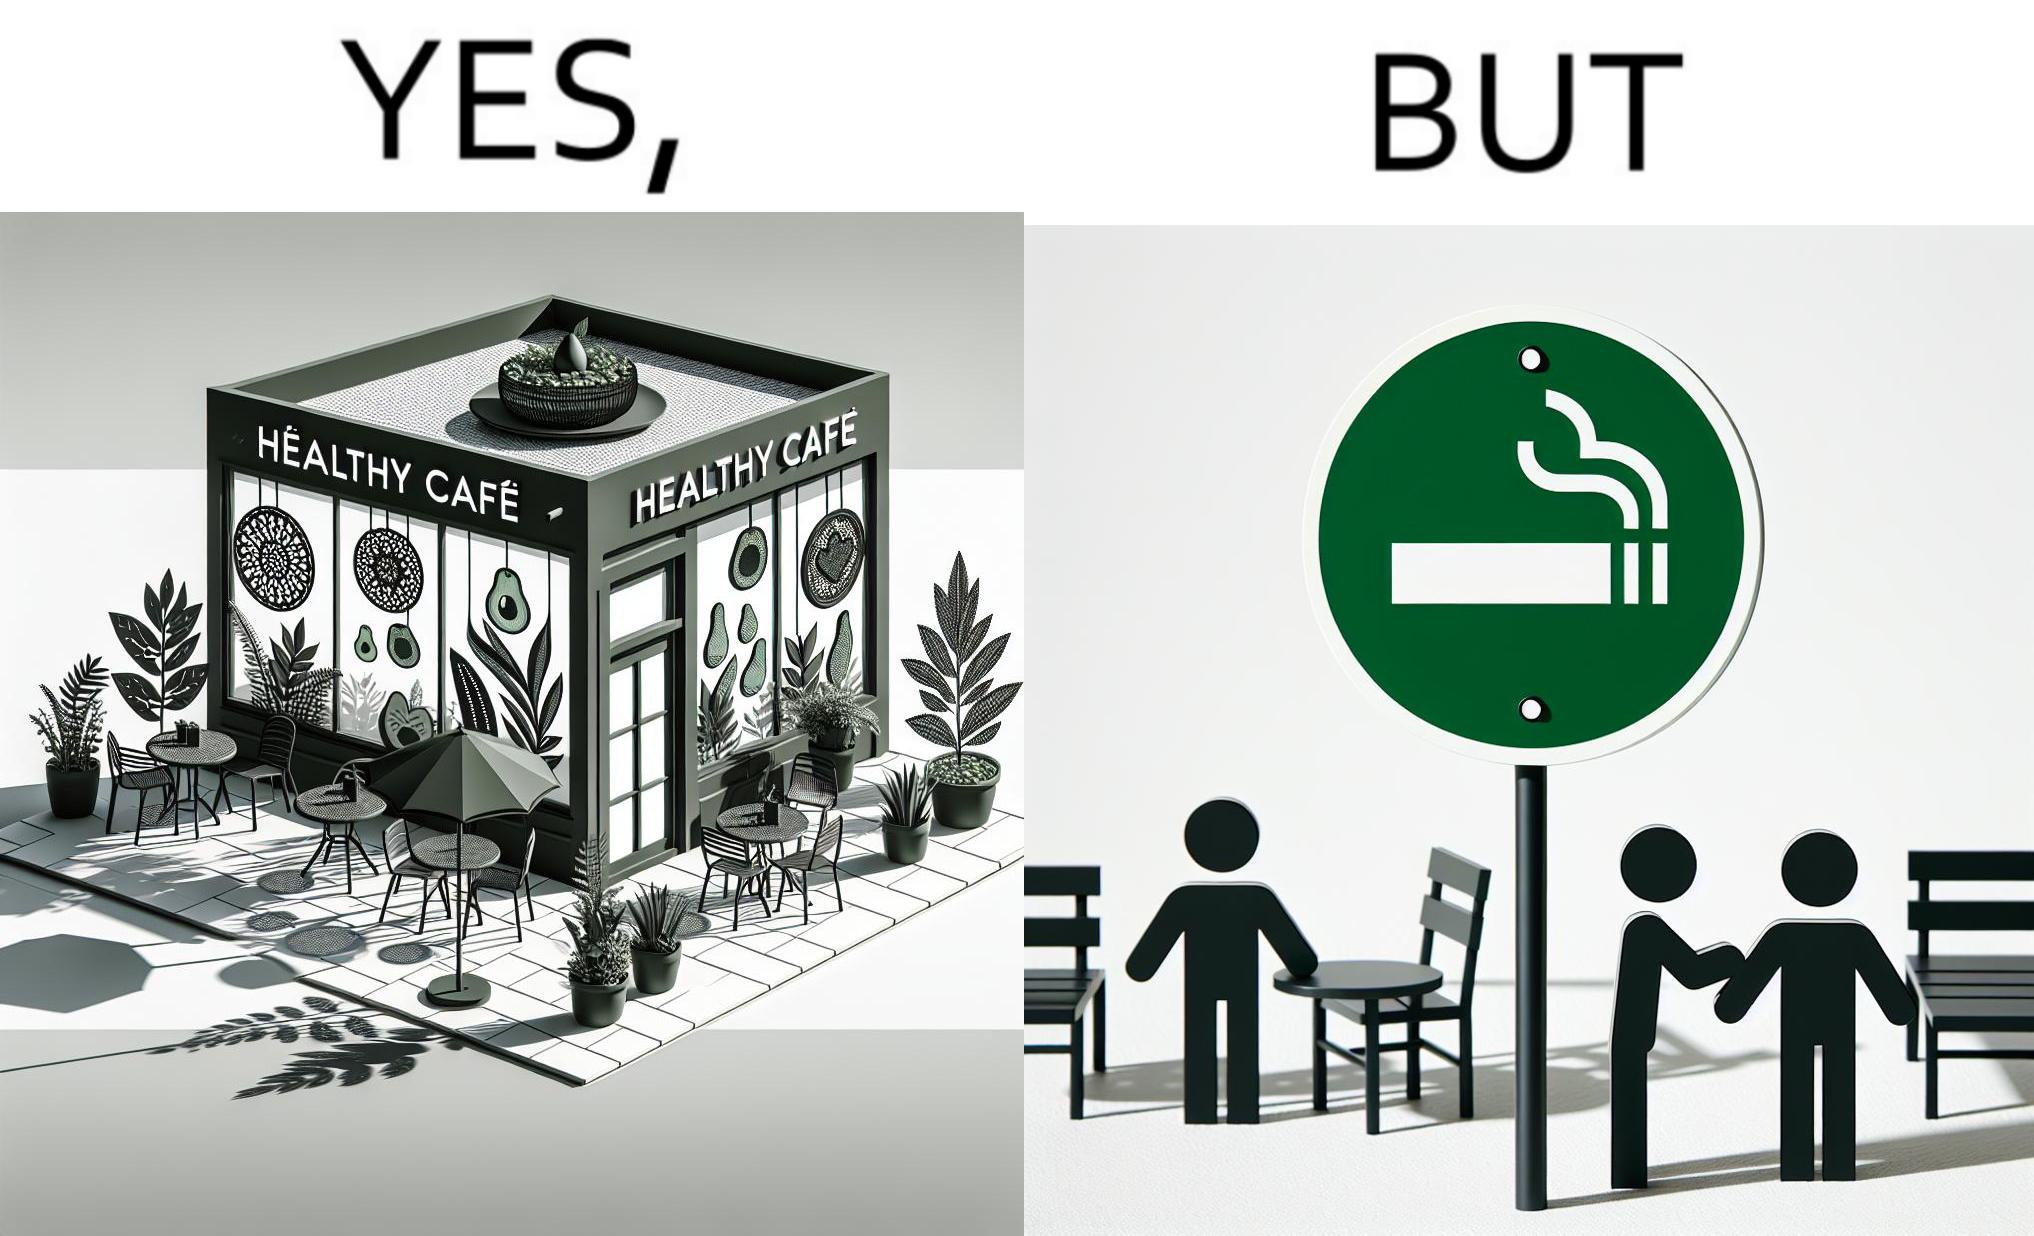What is shown in this image? This image is funny because an eatery that calls itself the "healthy" cafe also has a smoking area, which is not very "healthy". If it really was a healthy cafe, it would not have a smoking area as smoking is injurious to health. Satire on the behavior of humans - both those that operate this cafe who made the decision of allowing smoking and creating a designated smoking area, and those that visit this healthy cafe to become "healthy", but then also indulge in very unhealthy habits simultaneously. 